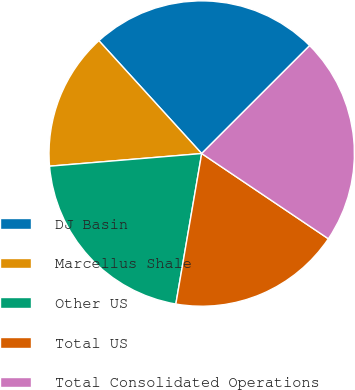Convert chart. <chart><loc_0><loc_0><loc_500><loc_500><pie_chart><fcel>DJ Basin<fcel>Marcellus Shale<fcel>Other US<fcel>Total US<fcel>Total Consolidated Operations<nl><fcel>24.26%<fcel>14.56%<fcel>20.97%<fcel>18.28%<fcel>21.92%<nl></chart> 